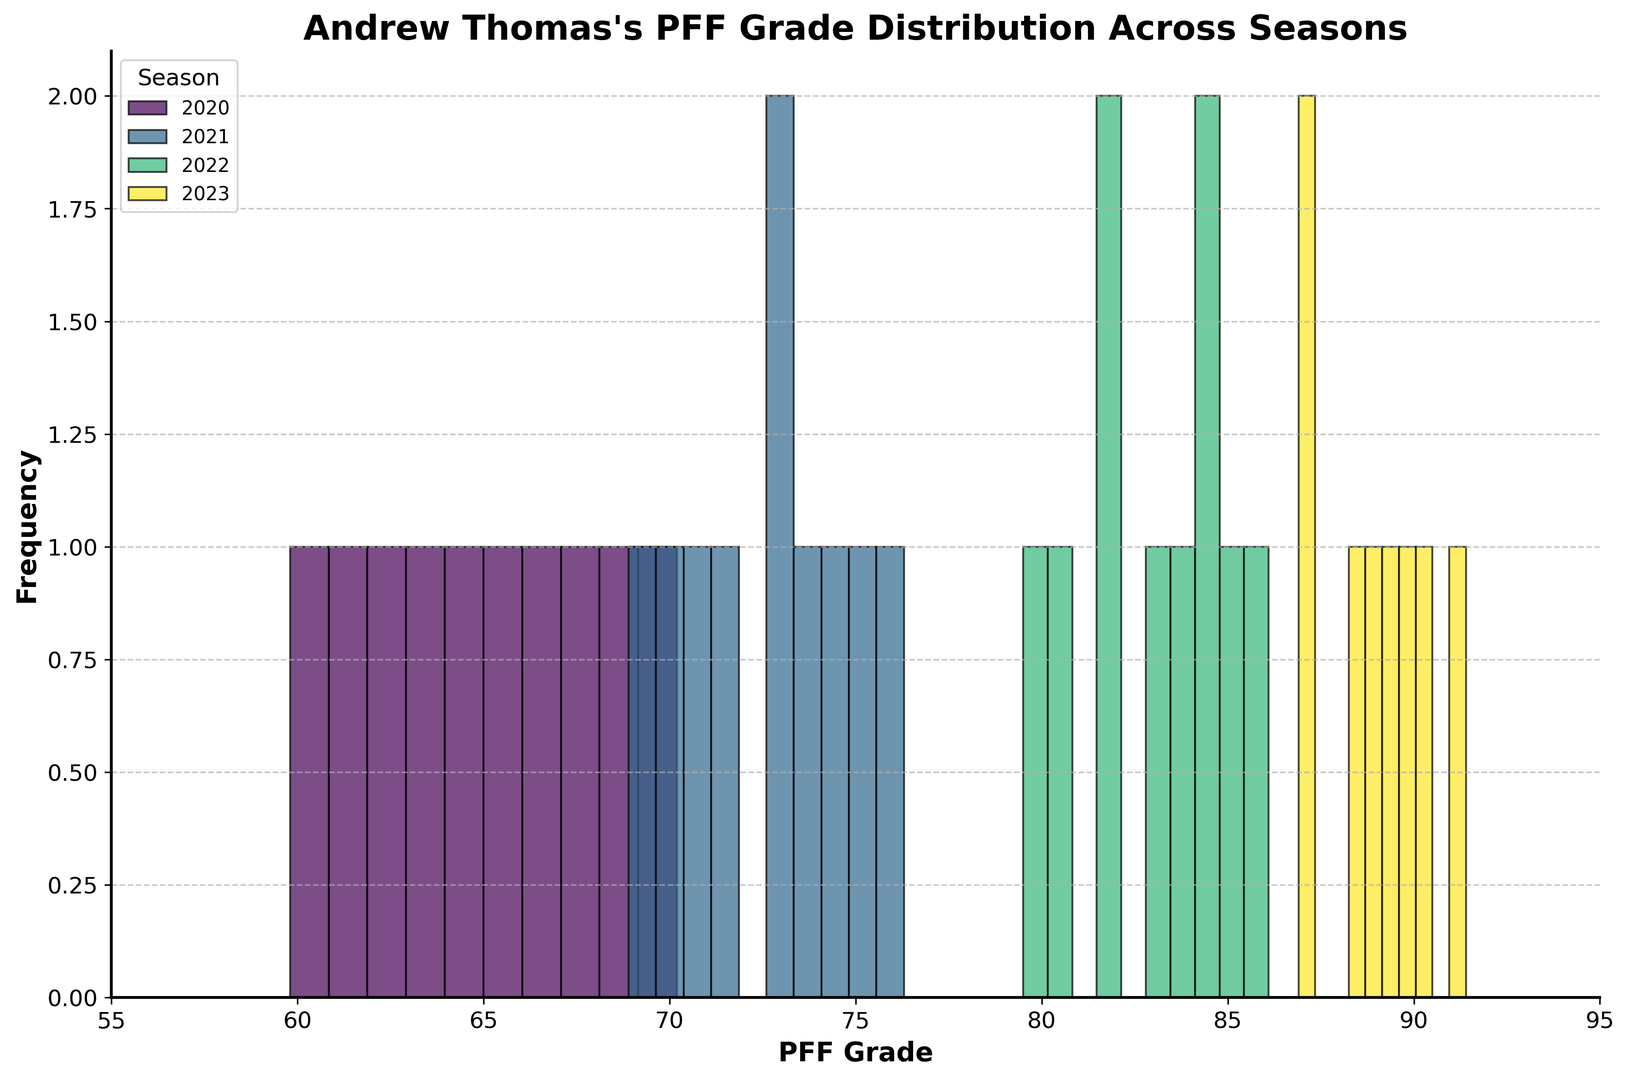How many unique seasons are represented in the figure? Count the number of different seasons shown in the legend. The legend indicates four seasons: 2020, 2021, 2022, and 2023.
Answer: 4 Which season has the highest range of PFF grades? The range is the difference between the highest and lowest grades for each season. By visually inspecting the histograms, season 2023 ranges from approximately 86.9 to 91.4, which is around 4.5 units. Compare this to the other seasons to see that 2023 has the highest range.
Answer: 2023 What is the most frequent PFF grade range for the 2020 season? Look at the histogram bars for 2020 and identify which range has the tallest bar, indicating the highest frequency of grades. The tallest bar for 2020 appears around the 60-65 grade range.
Answer: 60-65 Which season shows an overall improvement in PFF grades compared to the previous season? Compare the histograms of consecutive seasons. Notice that the grades for 2021 are mostly higher than those of 2020, and the grades for 2022 are higher than those of 2021. The most significant improvement is seen for the 2022 season, which has consistently higher grades compared to 2021.
Answer: 2022 Do any seasons have overlapping PFF grade ranges? Observing the histograms, identify if any bars from different seasons overlap. The 2021 season overlaps slightly with the 2020 season in the 68-70 range and overlaps significantly with the 2022 season in the 70-76 range.
Answer: Yes Which season has the least variation in PFF grades? The variation can be inferred by the spread of bars in the histogram. The season with the tightest cluster of bars has the least variation. Season 2023 has bars that cluster closely together between 86.9 and 91.4.
Answer: 2023 What is the highest PFF grade recorded across all seasons? Find the highest bar across all histograms. The highest PFF grade is approximately 91.4 in season 2023.
Answer: 91.4 Does the frequency of high PFF grades (80 and above) increase over the seasons? Check the histograms and count the number of grades 80 and above for each season. There are more frequent higher grades in 2022 compared to 2021, and 2023 continues to have frequent high grades (majority are above 86.9).
Answer: Yes Which season has the widest distribution of PFF grades? The widest distribution is indicated by the broader spread of bars in the histogram. Season 2020 has grades ranging from approximately 59.8 to 70.2, approximately an 11-point range.
Answer: 2020 